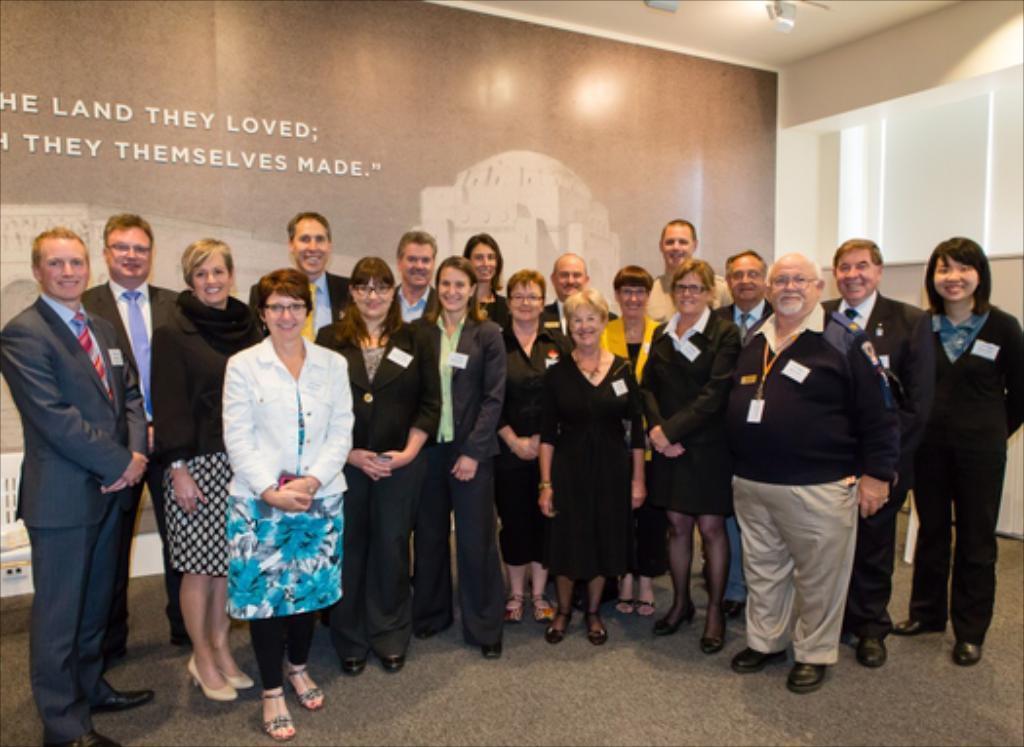Can you describe this image briefly? In this image in front there are a few people standing on the floor and they were wearing a smile on their faces. Behind them there is a wall and on the wall there is a painting and some text written on it. 